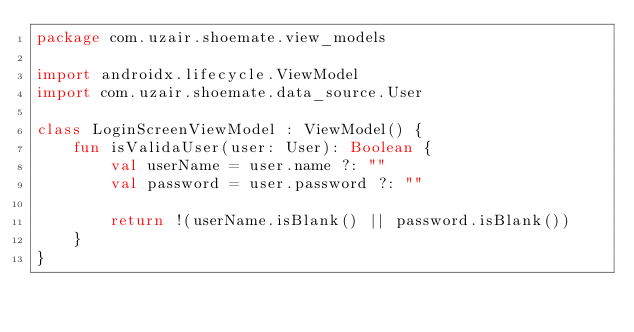Convert code to text. <code><loc_0><loc_0><loc_500><loc_500><_Kotlin_>package com.uzair.shoemate.view_models

import androidx.lifecycle.ViewModel
import com.uzair.shoemate.data_source.User

class LoginScreenViewModel : ViewModel() {
    fun isValidaUser(user: User): Boolean {
        val userName = user.name ?: ""
        val password = user.password ?: ""

        return !(userName.isBlank() || password.isBlank())
    }
}</code> 